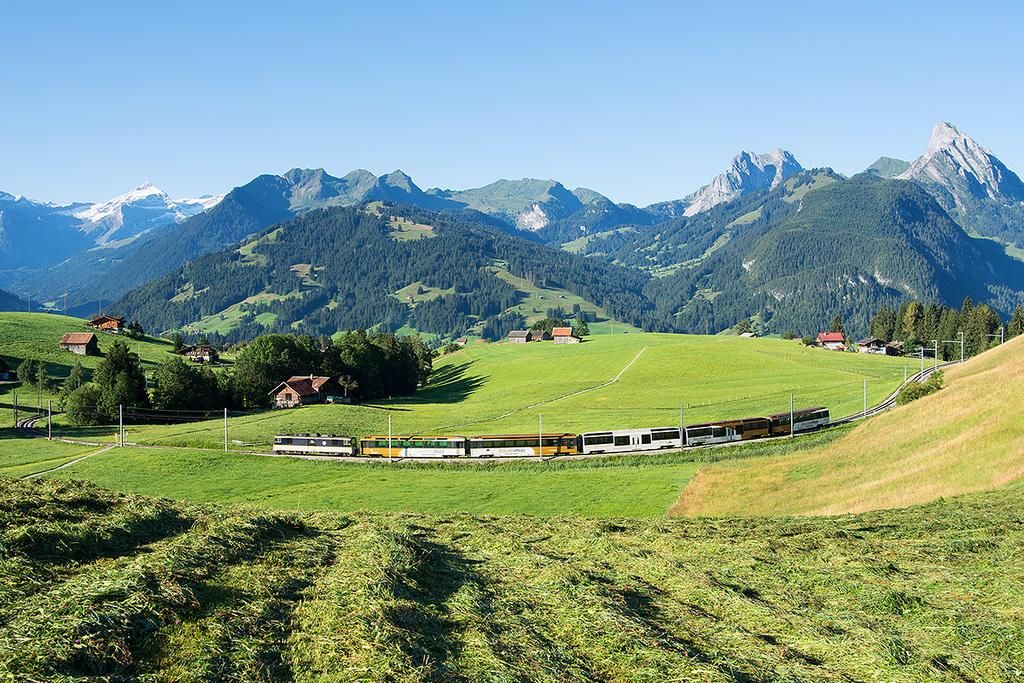What is the main subject of the image? The main subject of the image is a train on the track. What else can be seen in the image besides the train? There are houses, plants, trees, poles, mountains, grass, and the sky visible in the image. Can you describe the natural elements in the image? The natural elements include trees, grass, and mountains. What is the background of the image? The sky is visible in the background of the image. What type of leather material can be seen on the cushion in the image? There is no cushion or leather material present in the image. 